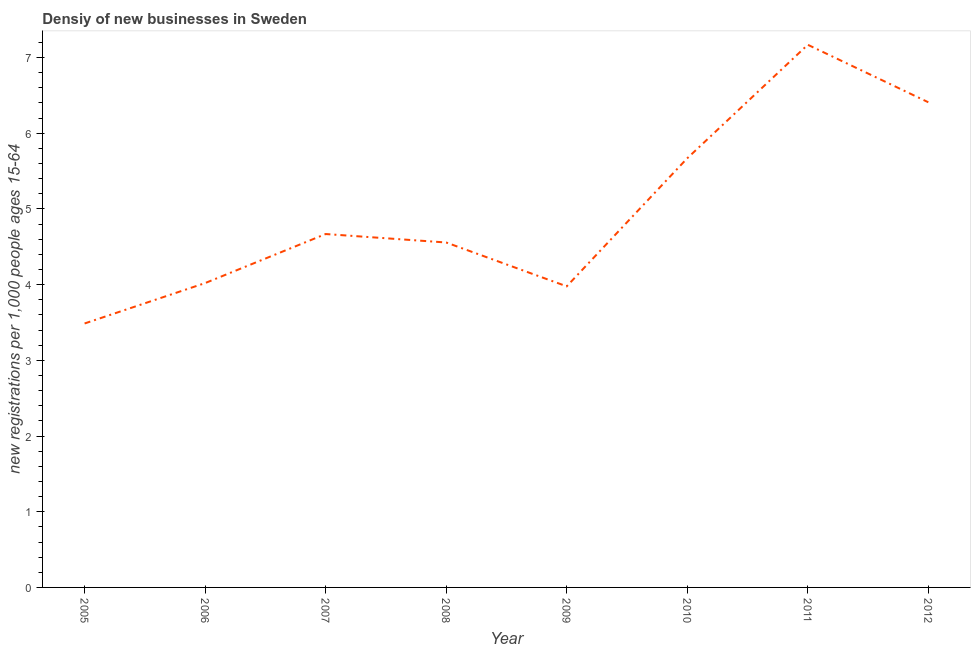What is the density of new business in 2007?
Provide a short and direct response. 4.67. Across all years, what is the maximum density of new business?
Offer a very short reply. 7.17. Across all years, what is the minimum density of new business?
Offer a terse response. 3.49. In which year was the density of new business maximum?
Your answer should be very brief. 2011. In which year was the density of new business minimum?
Your answer should be compact. 2005. What is the sum of the density of new business?
Provide a succinct answer. 39.95. What is the difference between the density of new business in 2009 and 2011?
Provide a short and direct response. -3.19. What is the average density of new business per year?
Your response must be concise. 4.99. What is the median density of new business?
Your response must be concise. 4.61. In how many years, is the density of new business greater than 2.6 ?
Make the answer very short. 8. What is the ratio of the density of new business in 2008 to that in 2012?
Keep it short and to the point. 0.71. Is the difference between the density of new business in 2008 and 2012 greater than the difference between any two years?
Your response must be concise. No. What is the difference between the highest and the second highest density of new business?
Give a very brief answer. 0.76. Is the sum of the density of new business in 2010 and 2012 greater than the maximum density of new business across all years?
Offer a terse response. Yes. What is the difference between the highest and the lowest density of new business?
Your answer should be very brief. 3.68. How many lines are there?
Your answer should be very brief. 1. How many years are there in the graph?
Make the answer very short. 8. Are the values on the major ticks of Y-axis written in scientific E-notation?
Offer a terse response. No. What is the title of the graph?
Offer a terse response. Densiy of new businesses in Sweden. What is the label or title of the X-axis?
Offer a terse response. Year. What is the label or title of the Y-axis?
Provide a succinct answer. New registrations per 1,0 people ages 15-64. What is the new registrations per 1,000 people ages 15-64 of 2005?
Provide a short and direct response. 3.49. What is the new registrations per 1,000 people ages 15-64 of 2006?
Offer a terse response. 4.02. What is the new registrations per 1,000 people ages 15-64 in 2007?
Make the answer very short. 4.67. What is the new registrations per 1,000 people ages 15-64 of 2008?
Offer a terse response. 4.56. What is the new registrations per 1,000 people ages 15-64 in 2009?
Make the answer very short. 3.98. What is the new registrations per 1,000 people ages 15-64 of 2010?
Your answer should be compact. 5.67. What is the new registrations per 1,000 people ages 15-64 in 2011?
Provide a short and direct response. 7.17. What is the new registrations per 1,000 people ages 15-64 of 2012?
Give a very brief answer. 6.41. What is the difference between the new registrations per 1,000 people ages 15-64 in 2005 and 2006?
Make the answer very short. -0.53. What is the difference between the new registrations per 1,000 people ages 15-64 in 2005 and 2007?
Your answer should be compact. -1.18. What is the difference between the new registrations per 1,000 people ages 15-64 in 2005 and 2008?
Offer a very short reply. -1.07. What is the difference between the new registrations per 1,000 people ages 15-64 in 2005 and 2009?
Your answer should be very brief. -0.49. What is the difference between the new registrations per 1,000 people ages 15-64 in 2005 and 2010?
Provide a succinct answer. -2.18. What is the difference between the new registrations per 1,000 people ages 15-64 in 2005 and 2011?
Ensure brevity in your answer.  -3.68. What is the difference between the new registrations per 1,000 people ages 15-64 in 2005 and 2012?
Your answer should be compact. -2.92. What is the difference between the new registrations per 1,000 people ages 15-64 in 2006 and 2007?
Offer a terse response. -0.65. What is the difference between the new registrations per 1,000 people ages 15-64 in 2006 and 2008?
Provide a short and direct response. -0.54. What is the difference between the new registrations per 1,000 people ages 15-64 in 2006 and 2009?
Your answer should be compact. 0.04. What is the difference between the new registrations per 1,000 people ages 15-64 in 2006 and 2010?
Provide a short and direct response. -1.65. What is the difference between the new registrations per 1,000 people ages 15-64 in 2006 and 2011?
Ensure brevity in your answer.  -3.15. What is the difference between the new registrations per 1,000 people ages 15-64 in 2006 and 2012?
Offer a terse response. -2.39. What is the difference between the new registrations per 1,000 people ages 15-64 in 2007 and 2008?
Your response must be concise. 0.11. What is the difference between the new registrations per 1,000 people ages 15-64 in 2007 and 2009?
Your answer should be compact. 0.69. What is the difference between the new registrations per 1,000 people ages 15-64 in 2007 and 2010?
Keep it short and to the point. -1. What is the difference between the new registrations per 1,000 people ages 15-64 in 2007 and 2011?
Your response must be concise. -2.5. What is the difference between the new registrations per 1,000 people ages 15-64 in 2007 and 2012?
Keep it short and to the point. -1.74. What is the difference between the new registrations per 1,000 people ages 15-64 in 2008 and 2009?
Your answer should be compact. 0.58. What is the difference between the new registrations per 1,000 people ages 15-64 in 2008 and 2010?
Your answer should be compact. -1.11. What is the difference between the new registrations per 1,000 people ages 15-64 in 2008 and 2011?
Offer a very short reply. -2.61. What is the difference between the new registrations per 1,000 people ages 15-64 in 2008 and 2012?
Give a very brief answer. -1.85. What is the difference between the new registrations per 1,000 people ages 15-64 in 2009 and 2010?
Offer a terse response. -1.69. What is the difference between the new registrations per 1,000 people ages 15-64 in 2009 and 2011?
Give a very brief answer. -3.19. What is the difference between the new registrations per 1,000 people ages 15-64 in 2009 and 2012?
Provide a succinct answer. -2.43. What is the difference between the new registrations per 1,000 people ages 15-64 in 2010 and 2011?
Ensure brevity in your answer.  -1.5. What is the difference between the new registrations per 1,000 people ages 15-64 in 2010 and 2012?
Keep it short and to the point. -0.74. What is the difference between the new registrations per 1,000 people ages 15-64 in 2011 and 2012?
Provide a succinct answer. 0.76. What is the ratio of the new registrations per 1,000 people ages 15-64 in 2005 to that in 2006?
Make the answer very short. 0.87. What is the ratio of the new registrations per 1,000 people ages 15-64 in 2005 to that in 2007?
Ensure brevity in your answer.  0.75. What is the ratio of the new registrations per 1,000 people ages 15-64 in 2005 to that in 2008?
Provide a short and direct response. 0.77. What is the ratio of the new registrations per 1,000 people ages 15-64 in 2005 to that in 2009?
Keep it short and to the point. 0.88. What is the ratio of the new registrations per 1,000 people ages 15-64 in 2005 to that in 2010?
Offer a terse response. 0.61. What is the ratio of the new registrations per 1,000 people ages 15-64 in 2005 to that in 2011?
Give a very brief answer. 0.49. What is the ratio of the new registrations per 1,000 people ages 15-64 in 2005 to that in 2012?
Keep it short and to the point. 0.54. What is the ratio of the new registrations per 1,000 people ages 15-64 in 2006 to that in 2007?
Make the answer very short. 0.86. What is the ratio of the new registrations per 1,000 people ages 15-64 in 2006 to that in 2008?
Provide a short and direct response. 0.88. What is the ratio of the new registrations per 1,000 people ages 15-64 in 2006 to that in 2009?
Your answer should be very brief. 1.01. What is the ratio of the new registrations per 1,000 people ages 15-64 in 2006 to that in 2010?
Keep it short and to the point. 0.71. What is the ratio of the new registrations per 1,000 people ages 15-64 in 2006 to that in 2011?
Keep it short and to the point. 0.56. What is the ratio of the new registrations per 1,000 people ages 15-64 in 2006 to that in 2012?
Provide a short and direct response. 0.63. What is the ratio of the new registrations per 1,000 people ages 15-64 in 2007 to that in 2009?
Give a very brief answer. 1.17. What is the ratio of the new registrations per 1,000 people ages 15-64 in 2007 to that in 2010?
Your answer should be compact. 0.82. What is the ratio of the new registrations per 1,000 people ages 15-64 in 2007 to that in 2011?
Provide a succinct answer. 0.65. What is the ratio of the new registrations per 1,000 people ages 15-64 in 2007 to that in 2012?
Make the answer very short. 0.73. What is the ratio of the new registrations per 1,000 people ages 15-64 in 2008 to that in 2009?
Offer a very short reply. 1.15. What is the ratio of the new registrations per 1,000 people ages 15-64 in 2008 to that in 2010?
Your answer should be very brief. 0.8. What is the ratio of the new registrations per 1,000 people ages 15-64 in 2008 to that in 2011?
Your answer should be compact. 0.64. What is the ratio of the new registrations per 1,000 people ages 15-64 in 2008 to that in 2012?
Offer a terse response. 0.71. What is the ratio of the new registrations per 1,000 people ages 15-64 in 2009 to that in 2010?
Ensure brevity in your answer.  0.7. What is the ratio of the new registrations per 1,000 people ages 15-64 in 2009 to that in 2011?
Provide a succinct answer. 0.56. What is the ratio of the new registrations per 1,000 people ages 15-64 in 2009 to that in 2012?
Offer a very short reply. 0.62. What is the ratio of the new registrations per 1,000 people ages 15-64 in 2010 to that in 2011?
Provide a short and direct response. 0.79. What is the ratio of the new registrations per 1,000 people ages 15-64 in 2010 to that in 2012?
Provide a succinct answer. 0.89. What is the ratio of the new registrations per 1,000 people ages 15-64 in 2011 to that in 2012?
Your response must be concise. 1.12. 